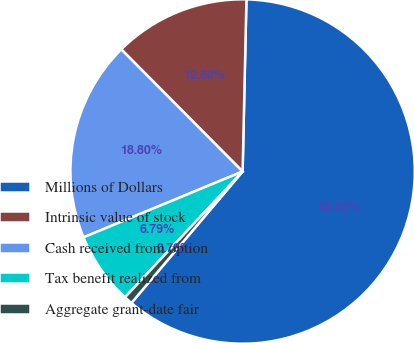Convert chart. <chart><loc_0><loc_0><loc_500><loc_500><pie_chart><fcel>Millions of Dollars<fcel>Intrinsic value of stock<fcel>Cash received from option<fcel>Tax benefit realized from<fcel>Aggregate grant-date fair<nl><fcel>60.82%<fcel>12.8%<fcel>18.8%<fcel>6.79%<fcel>0.79%<nl></chart> 